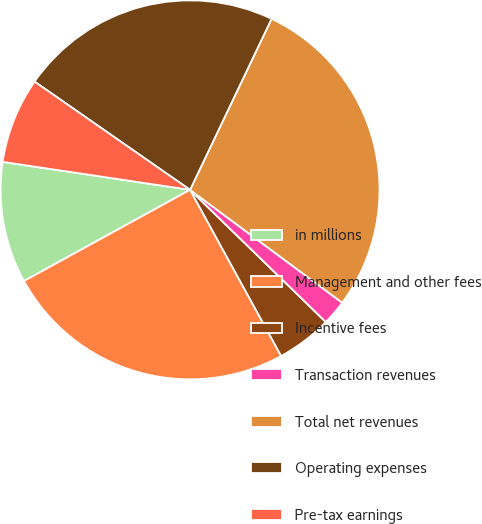Convert chart to OTSL. <chart><loc_0><loc_0><loc_500><loc_500><pie_chart><fcel>in millions<fcel>Management and other fees<fcel>Incentive fees<fcel>Transaction revenues<fcel>Total net revenues<fcel>Operating expenses<fcel>Pre-tax earnings<nl><fcel>10.35%<fcel>24.99%<fcel>4.73%<fcel>2.13%<fcel>28.08%<fcel>22.4%<fcel>7.32%<nl></chart> 